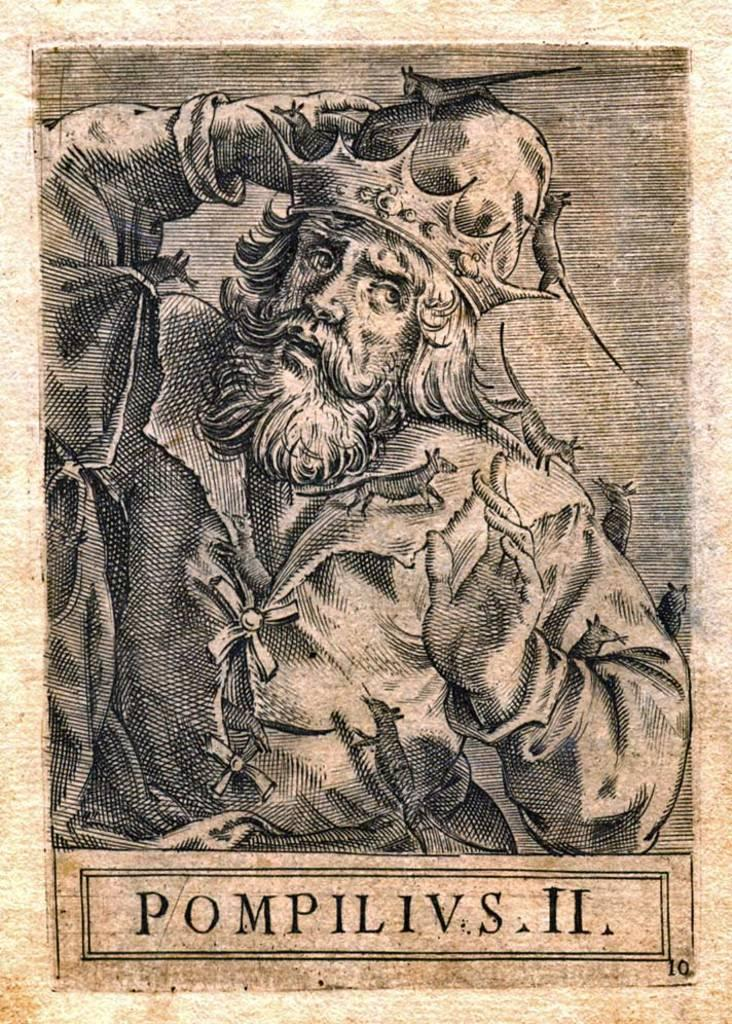Provide a one-sentence caption for the provided image. a page with a man drawn on it that reads: POMPILIVS II. 